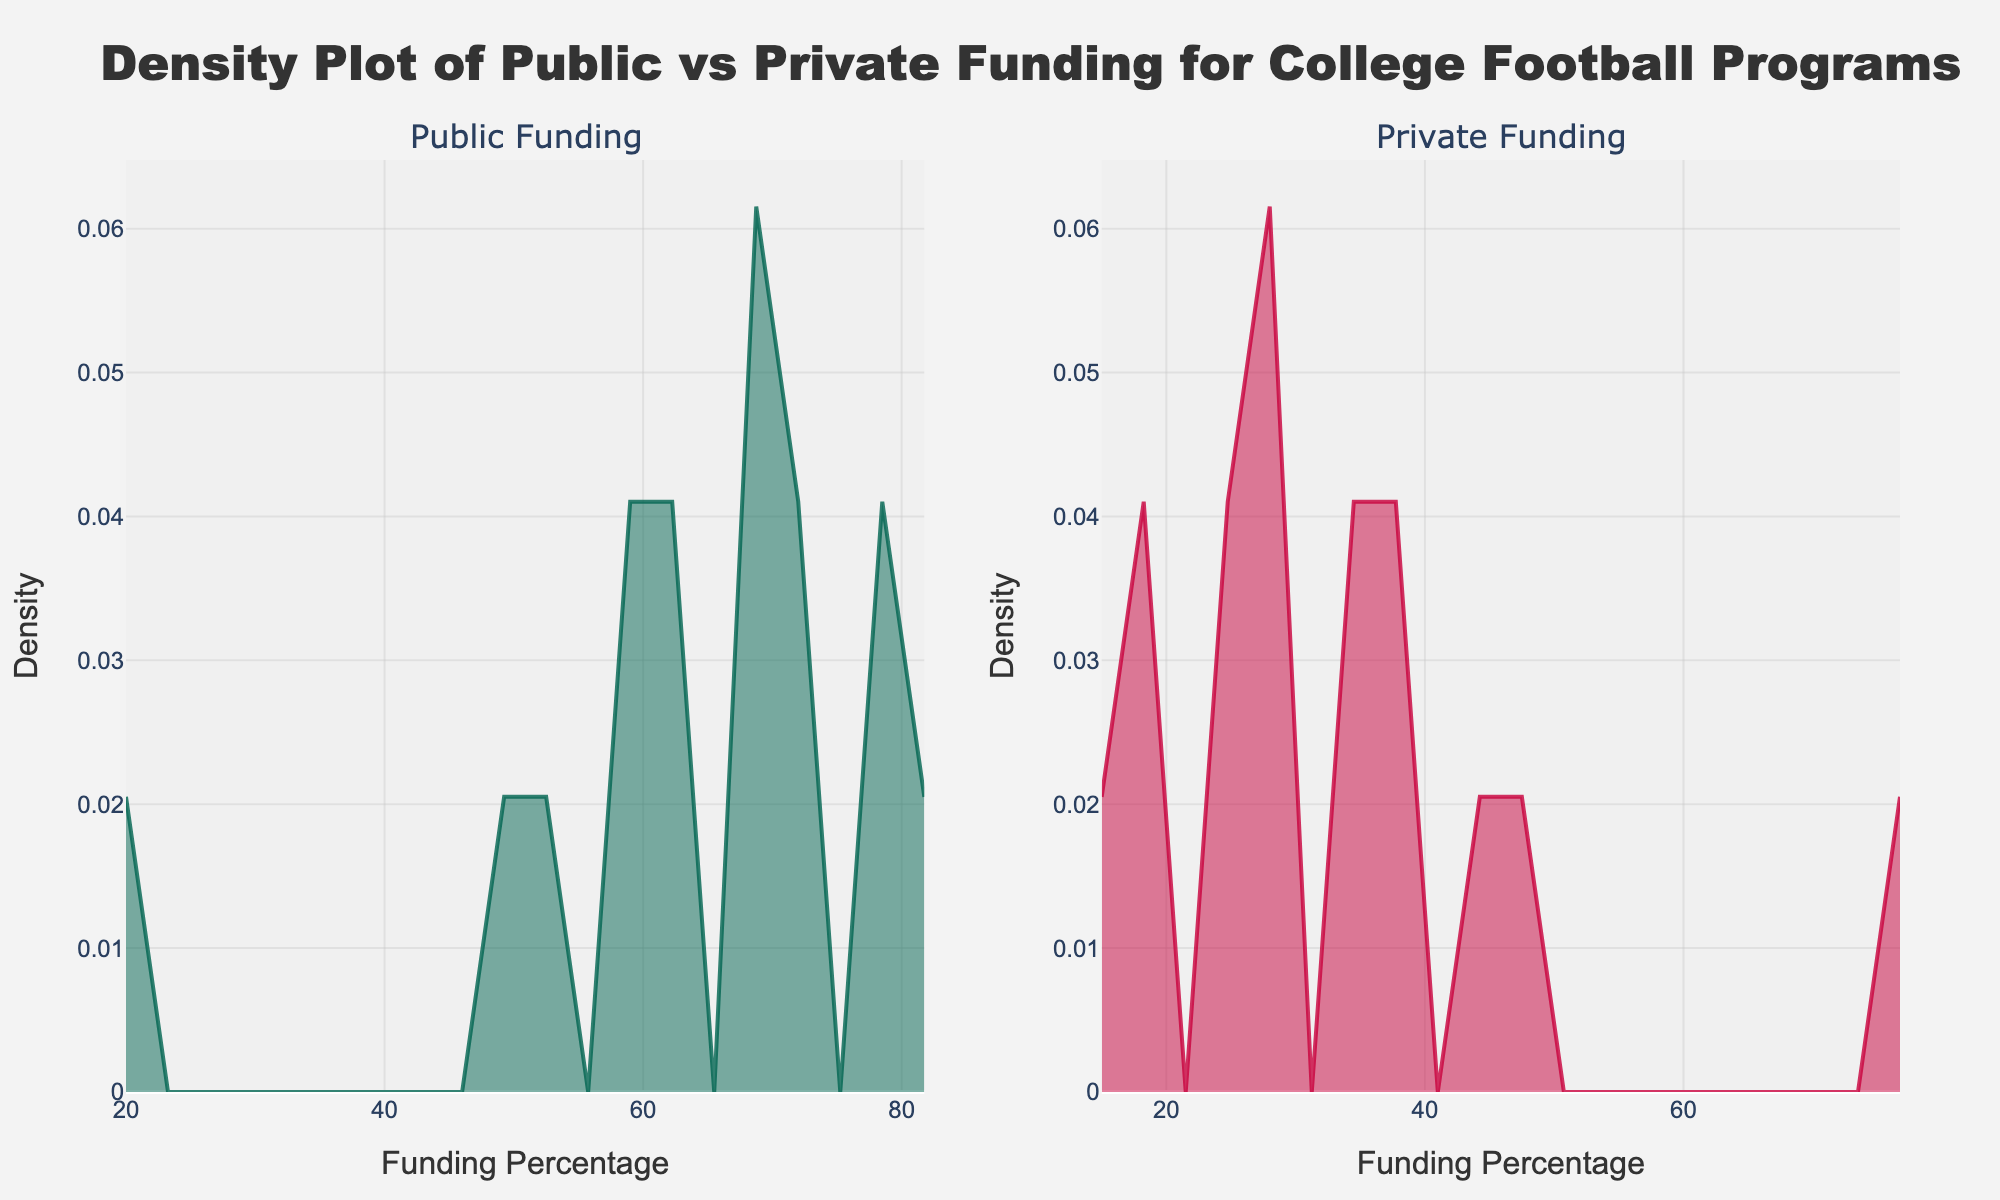What is the title of the figure? The title is displayed prominently at the top of the figure. It reads "Density Plot of Public vs Private Funding for College Football Programs".
Answer: Density Plot of Public vs Private Funding for College Football Programs Which subplot has a higher density peak, Public Funding or Private Funding? Look at the peak heights in each subplot. The peak in the Public Funding subplot is higher than the peak in the Private Funding subplot.
Answer: Public Funding What are the x-axis labels representing? The labels on the x-axis indicate the funding percentage for both subplots, showing percentages from 0 to 100%.
Answer: Funding Percentage What does the y-axis represent in this figure? The y-axis represents the density, which measures how the data distribution is spread out across funding percentages.
Answer: Density Which funding type shows a higher density around 70%? By examining the density curves, the density is higher around 70% for the Public Funding subplot compared to the Private Funding subplot.
Answer: Public Funding Compare the spread of data between Public and Private Funding. Which one is more widespread? The Private Funding subplot shows a more widespread distribution, indicated by the flatter curve compared to the sharper peak in the Public Funding subplot.
Answer: Private Funding Is there any funding percentage where the density is zero or nearly zero for both subplots? Check both subplots for any regions where the density curve drops to zero. In both subplots, the density near 0% and 100% is nearly zero.
Answer: Near 0% and 100% What is the common feature across the x-axes of both subplots? Both subplots have x-axes that are labeled "Funding Percentage" and range from 0 to 100%.
Answer: Labeled "Funding Percentage" and range from 0 to 100% If you were to summarize the overall pattern in both subplots, how would you describe it? The Public Funding subplot shows a concentration of density around higher percentages (60-80%), while the Private Funding subplot has a more even spread but peaks around 20-40%. This indicates that public funding is generally higher for the selected colleges.
Answer: Public higher (60-80%), Private more even (20-40%) Based on the density plots, could you infer which type of funding is more common for college football programs? Since the Public Funding subplot shows a much higher peak density around higher percentages (60-80%), it suggests that public funding is more common.
Answer: Public Funding 